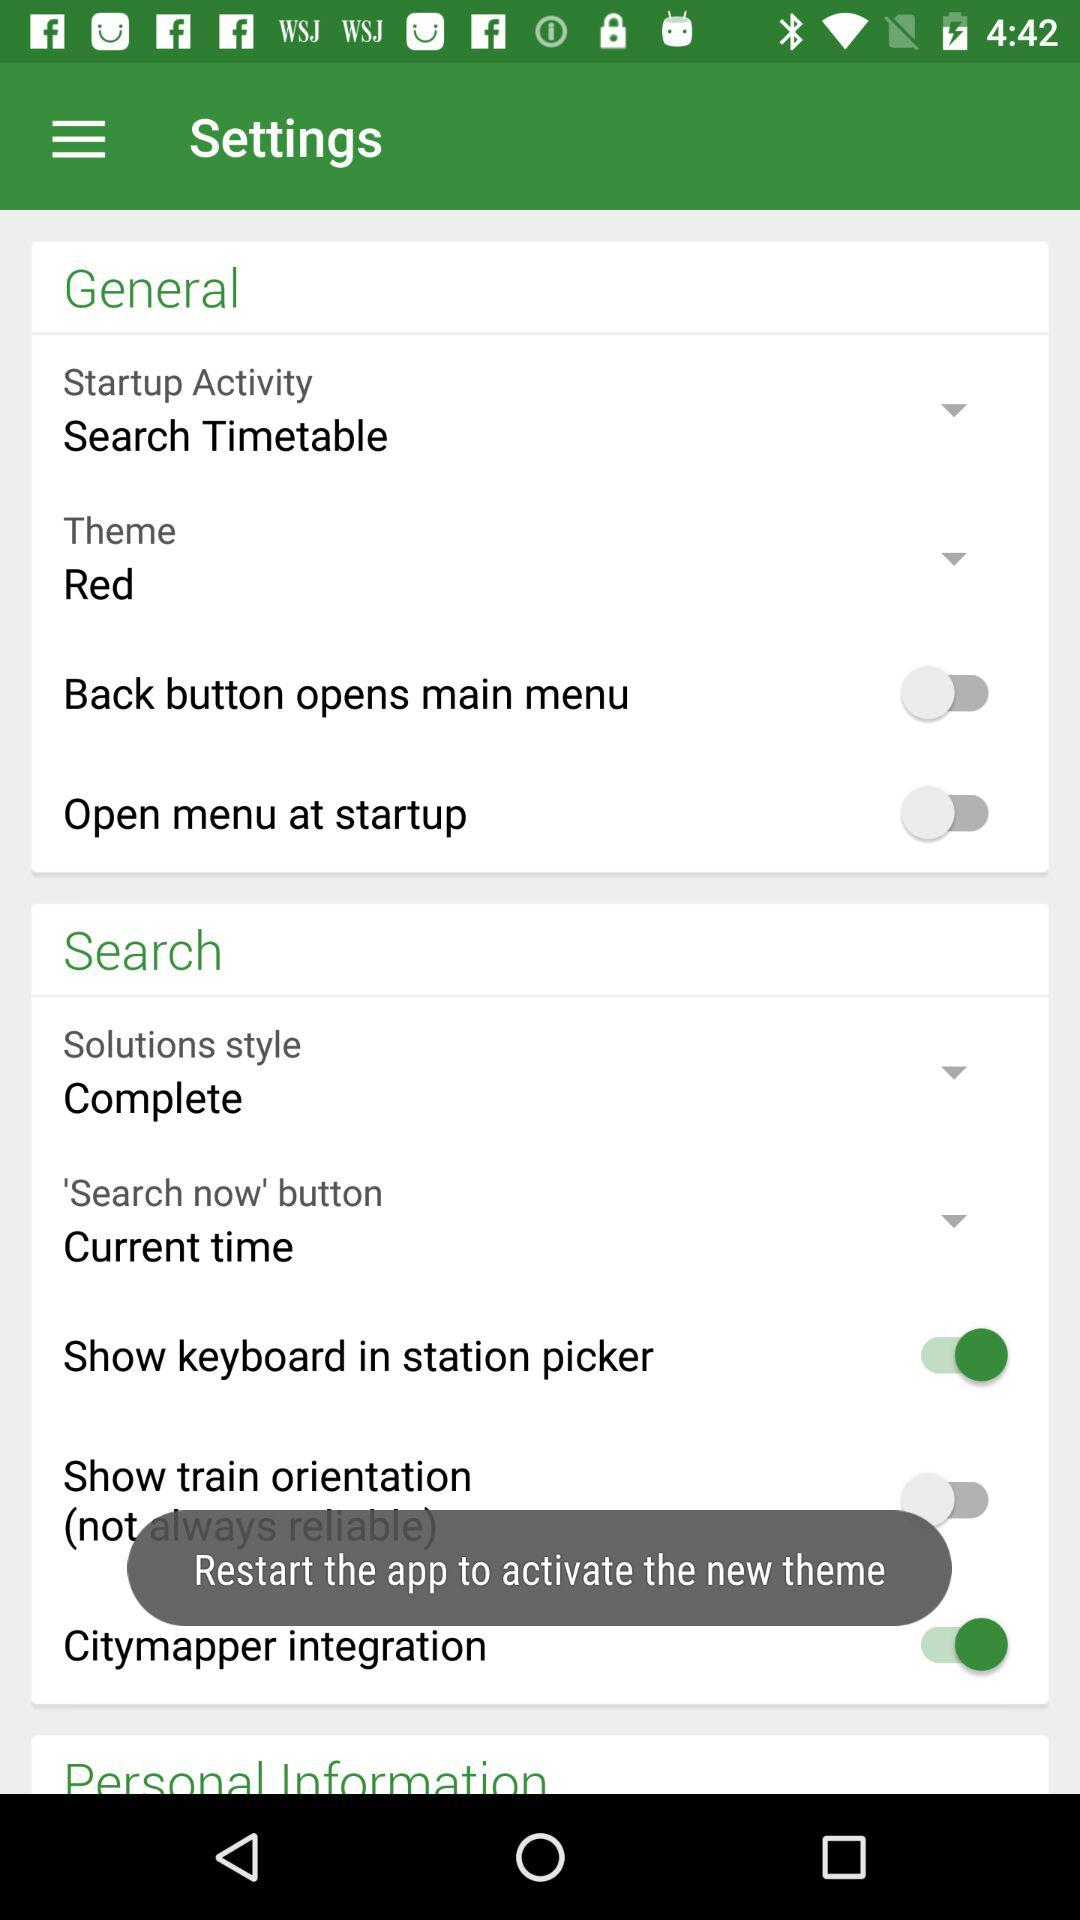What is the setting for "Open menu at startup"? The setting for "Open menu at startup" is "off". 